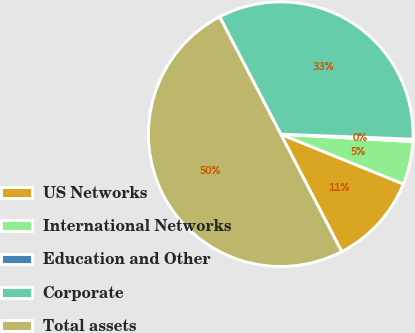Convert chart to OTSL. <chart><loc_0><loc_0><loc_500><loc_500><pie_chart><fcel>US Networks<fcel>International Networks<fcel>Education and Other<fcel>Corporate<fcel>Total assets<nl><fcel>11.24%<fcel>5.25%<fcel>0.29%<fcel>33.24%<fcel>49.98%<nl></chart> 